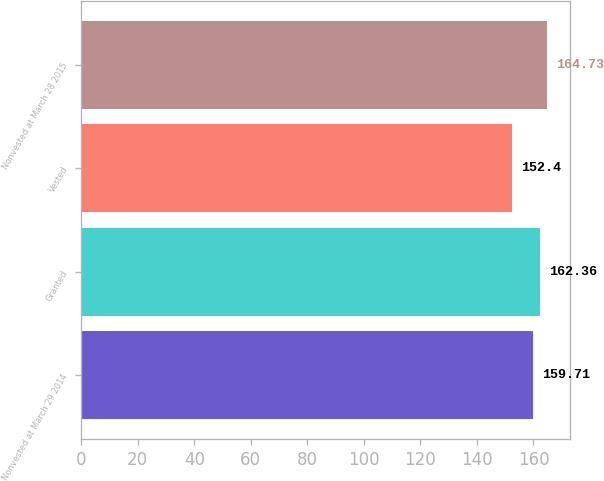<chart> <loc_0><loc_0><loc_500><loc_500><bar_chart><fcel>Nonvested at March 29 2014<fcel>Granted<fcel>Vested<fcel>Nonvested at March 28 2015<nl><fcel>159.71<fcel>162.36<fcel>152.4<fcel>164.73<nl></chart> 